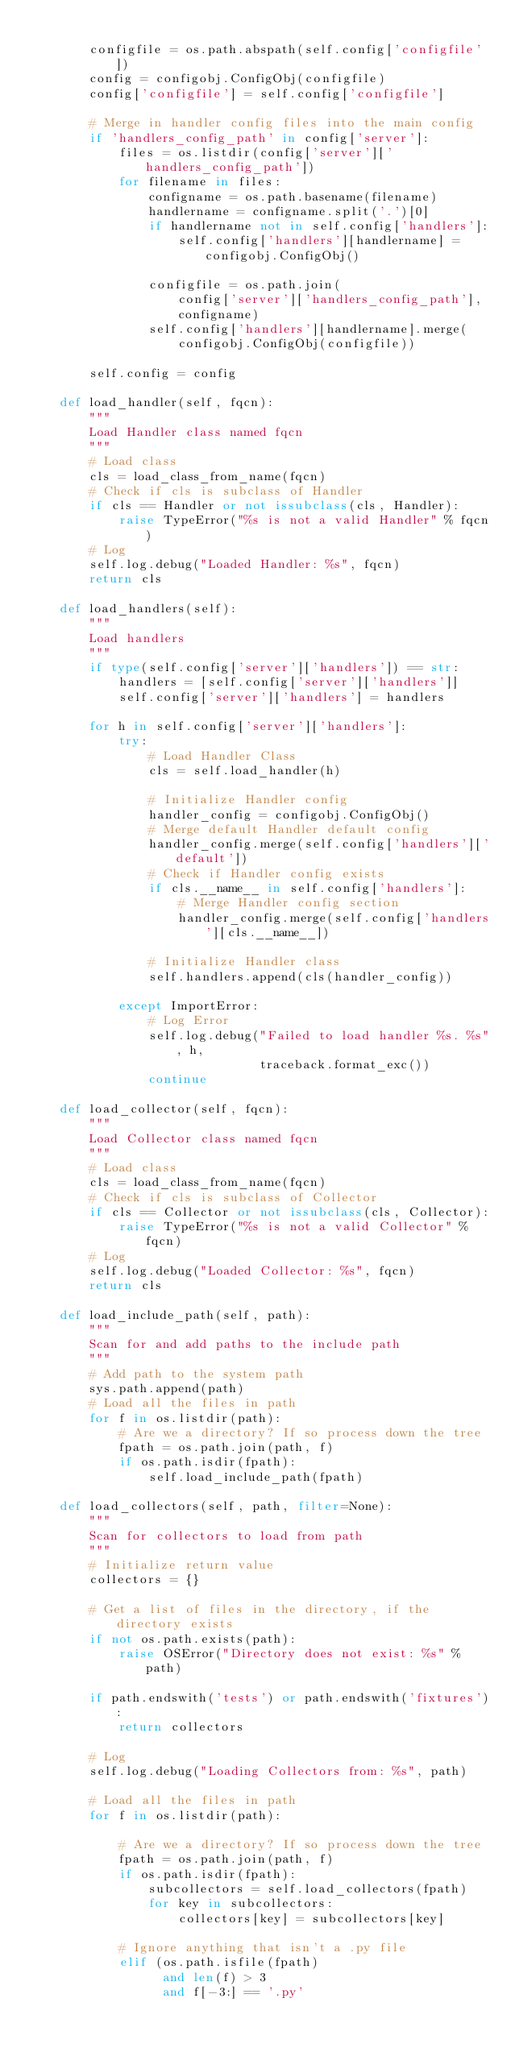<code> <loc_0><loc_0><loc_500><loc_500><_Python_>
        configfile = os.path.abspath(self.config['configfile'])
        config = configobj.ConfigObj(configfile)
        config['configfile'] = self.config['configfile']

        # Merge in handler config files into the main config
        if 'handlers_config_path' in config['server']:
            files = os.listdir(config['server']['handlers_config_path'])
            for filename in files:
                configname = os.path.basename(filename)
                handlername = configname.split('.')[0]
                if handlername not in self.config['handlers']:
                    self.config['handlers'][handlername] = configobj.ConfigObj()

                configfile = os.path.join(
                    config['server']['handlers_config_path'],
                    configname)
                self.config['handlers'][handlername].merge(
                    configobj.ConfigObj(configfile))

        self.config = config

    def load_handler(self, fqcn):
        """
        Load Handler class named fqcn
        """
        # Load class
        cls = load_class_from_name(fqcn)
        # Check if cls is subclass of Handler
        if cls == Handler or not issubclass(cls, Handler):
            raise TypeError("%s is not a valid Handler" % fqcn)
        # Log
        self.log.debug("Loaded Handler: %s", fqcn)
        return cls

    def load_handlers(self):
        """
        Load handlers
        """
        if type(self.config['server']['handlers']) == str:
            handlers = [self.config['server']['handlers']]
            self.config['server']['handlers'] = handlers

        for h in self.config['server']['handlers']:
            try:
                # Load Handler Class
                cls = self.load_handler(h)

                # Initialize Handler config
                handler_config = configobj.ConfigObj()
                # Merge default Handler default config
                handler_config.merge(self.config['handlers']['default'])
                # Check if Handler config exists
                if cls.__name__ in self.config['handlers']:
                    # Merge Handler config section
                    handler_config.merge(self.config['handlers'][cls.__name__])

                # Initialize Handler class
                self.handlers.append(cls(handler_config))

            except ImportError:
                # Log Error
                self.log.debug("Failed to load handler %s. %s", h,
                               traceback.format_exc())
                continue

    def load_collector(self, fqcn):
        """
        Load Collector class named fqcn
        """
        # Load class
        cls = load_class_from_name(fqcn)
        # Check if cls is subclass of Collector
        if cls == Collector or not issubclass(cls, Collector):
            raise TypeError("%s is not a valid Collector" % fqcn)
        # Log
        self.log.debug("Loaded Collector: %s", fqcn)
        return cls

    def load_include_path(self, path):
        """
        Scan for and add paths to the include path
        """
        # Add path to the system path
        sys.path.append(path)
        # Load all the files in path
        for f in os.listdir(path):
            # Are we a directory? If so process down the tree
            fpath = os.path.join(path, f)
            if os.path.isdir(fpath):
                self.load_include_path(fpath)

    def load_collectors(self, path, filter=None):
        """
        Scan for collectors to load from path
        """
        # Initialize return value
        collectors = {}

        # Get a list of files in the directory, if the directory exists
        if not os.path.exists(path):
            raise OSError("Directory does not exist: %s" % path)

        if path.endswith('tests') or path.endswith('fixtures'):
            return collectors

        # Log
        self.log.debug("Loading Collectors from: %s", path)

        # Load all the files in path
        for f in os.listdir(path):

            # Are we a directory? If so process down the tree
            fpath = os.path.join(path, f)
            if os.path.isdir(fpath):
                subcollectors = self.load_collectors(fpath)
                for key in subcollectors:
                    collectors[key] = subcollectors[key]

            # Ignore anything that isn't a .py file
            elif (os.path.isfile(fpath)
                  and len(f) > 3
                  and f[-3:] == '.py'</code> 